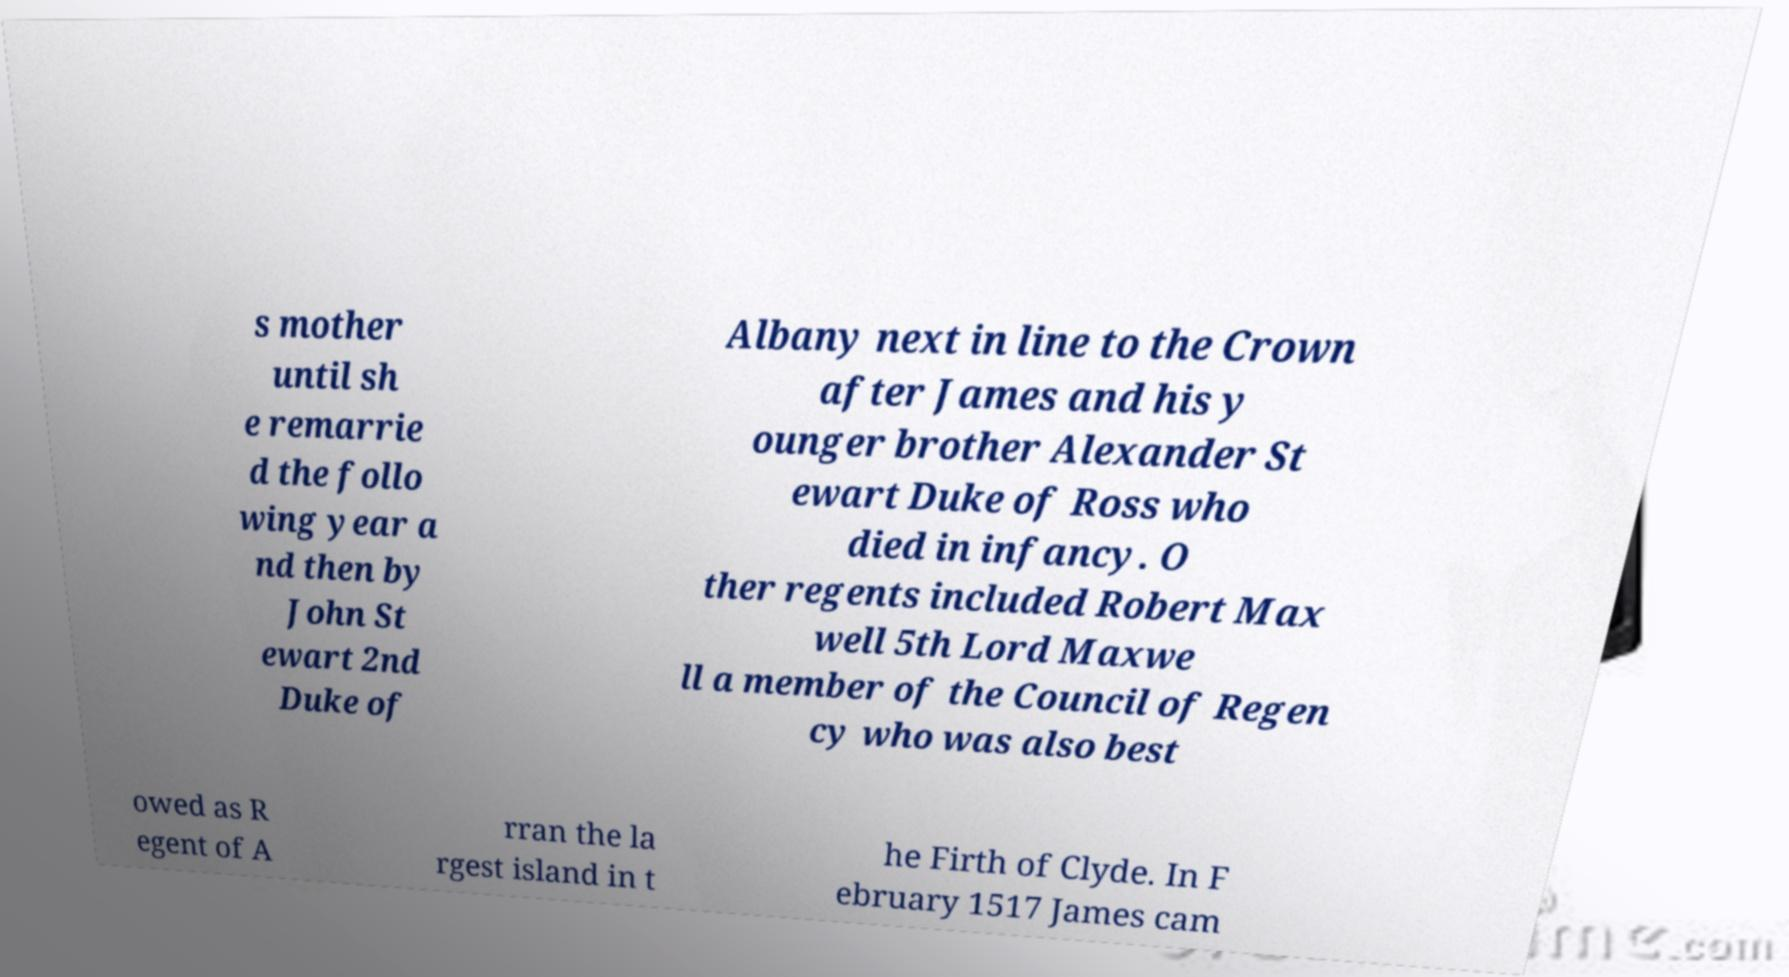Could you assist in decoding the text presented in this image and type it out clearly? s mother until sh e remarrie d the follo wing year a nd then by John St ewart 2nd Duke of Albany next in line to the Crown after James and his y ounger brother Alexander St ewart Duke of Ross who died in infancy. O ther regents included Robert Max well 5th Lord Maxwe ll a member of the Council of Regen cy who was also best owed as R egent of A rran the la rgest island in t he Firth of Clyde. In F ebruary 1517 James cam 